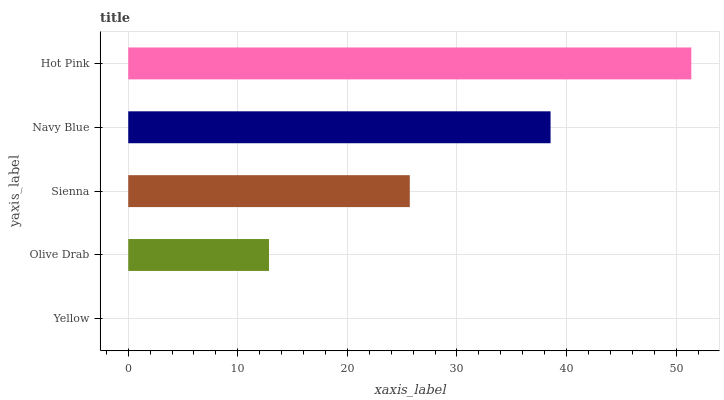Is Yellow the minimum?
Answer yes or no. Yes. Is Hot Pink the maximum?
Answer yes or no. Yes. Is Olive Drab the minimum?
Answer yes or no. No. Is Olive Drab the maximum?
Answer yes or no. No. Is Olive Drab greater than Yellow?
Answer yes or no. Yes. Is Yellow less than Olive Drab?
Answer yes or no. Yes. Is Yellow greater than Olive Drab?
Answer yes or no. No. Is Olive Drab less than Yellow?
Answer yes or no. No. Is Sienna the high median?
Answer yes or no. Yes. Is Sienna the low median?
Answer yes or no. Yes. Is Navy Blue the high median?
Answer yes or no. No. Is Olive Drab the low median?
Answer yes or no. No. 